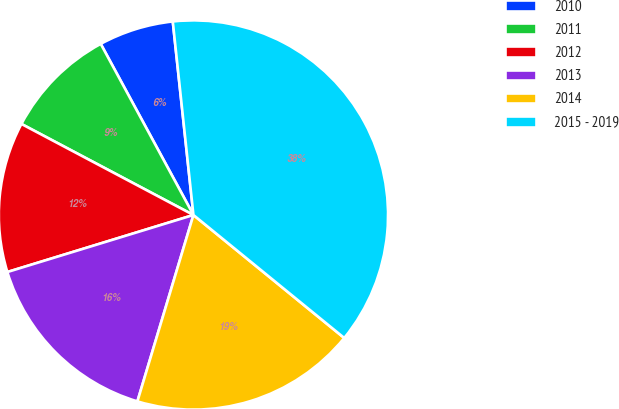Convert chart to OTSL. <chart><loc_0><loc_0><loc_500><loc_500><pie_chart><fcel>2010<fcel>2011<fcel>2012<fcel>2013<fcel>2014<fcel>2015 - 2019<nl><fcel>6.21%<fcel>9.35%<fcel>12.48%<fcel>15.62%<fcel>18.76%<fcel>37.58%<nl></chart> 